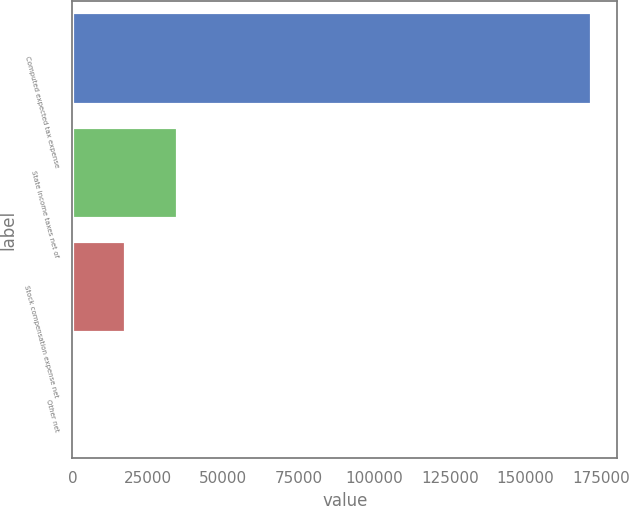Convert chart. <chart><loc_0><loc_0><loc_500><loc_500><bar_chart><fcel>Computed expected tax expense<fcel>State income taxes net of<fcel>Stock compensation expense net<fcel>Other net<nl><fcel>171849<fcel>34582.6<fcel>17424.3<fcel>266<nl></chart> 